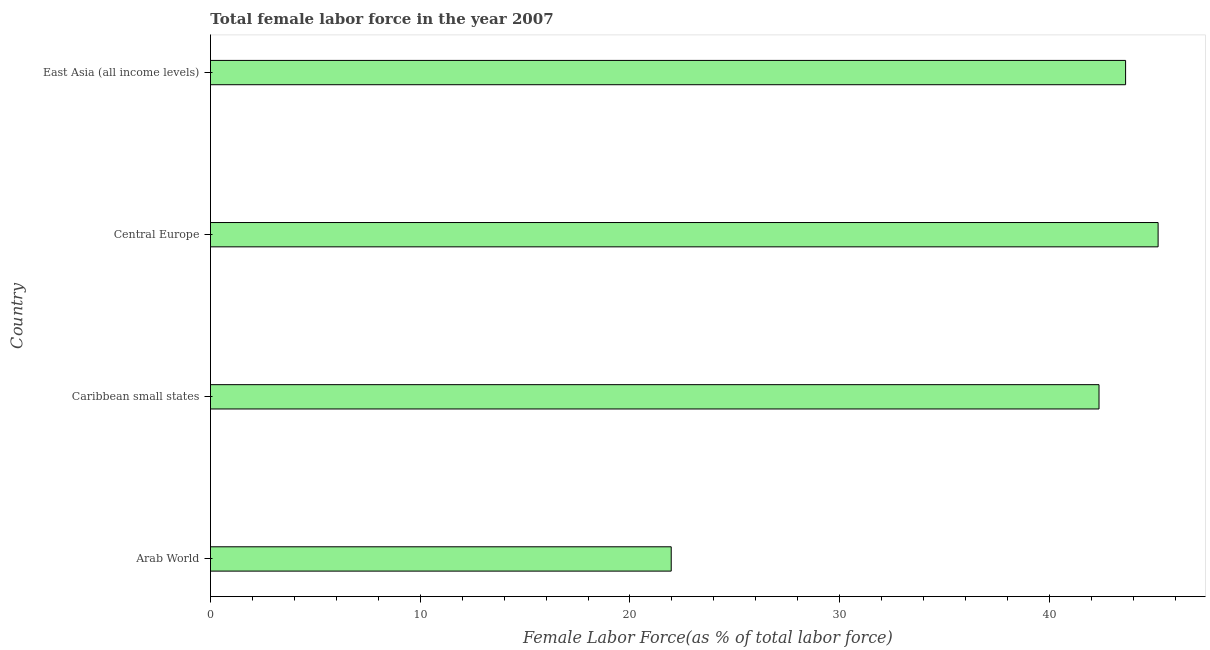Does the graph contain any zero values?
Ensure brevity in your answer.  No. What is the title of the graph?
Provide a succinct answer. Total female labor force in the year 2007. What is the label or title of the X-axis?
Offer a terse response. Female Labor Force(as % of total labor force). What is the total female labor force in Arab World?
Your response must be concise. 21.97. Across all countries, what is the maximum total female labor force?
Ensure brevity in your answer.  45.18. Across all countries, what is the minimum total female labor force?
Your answer should be compact. 21.97. In which country was the total female labor force maximum?
Your answer should be compact. Central Europe. In which country was the total female labor force minimum?
Provide a short and direct response. Arab World. What is the sum of the total female labor force?
Your response must be concise. 153.15. What is the difference between the total female labor force in Central Europe and East Asia (all income levels)?
Your answer should be very brief. 1.55. What is the average total female labor force per country?
Provide a succinct answer. 38.29. What is the median total female labor force?
Your response must be concise. 43. What is the ratio of the total female labor force in Arab World to that in Caribbean small states?
Offer a very short reply. 0.52. Is the total female labor force in Caribbean small states less than that in Central Europe?
Ensure brevity in your answer.  Yes. What is the difference between the highest and the second highest total female labor force?
Provide a short and direct response. 1.55. Is the sum of the total female labor force in Arab World and East Asia (all income levels) greater than the maximum total female labor force across all countries?
Ensure brevity in your answer.  Yes. What is the difference between the highest and the lowest total female labor force?
Your response must be concise. 23.21. In how many countries, is the total female labor force greater than the average total female labor force taken over all countries?
Give a very brief answer. 3. Are all the bars in the graph horizontal?
Your answer should be compact. Yes. How many countries are there in the graph?
Your response must be concise. 4. Are the values on the major ticks of X-axis written in scientific E-notation?
Provide a short and direct response. No. What is the Female Labor Force(as % of total labor force) of Arab World?
Ensure brevity in your answer.  21.97. What is the Female Labor Force(as % of total labor force) in Caribbean small states?
Ensure brevity in your answer.  42.36. What is the Female Labor Force(as % of total labor force) of Central Europe?
Your answer should be compact. 45.18. What is the Female Labor Force(as % of total labor force) in East Asia (all income levels)?
Make the answer very short. 43.63. What is the difference between the Female Labor Force(as % of total labor force) in Arab World and Caribbean small states?
Your response must be concise. -20.4. What is the difference between the Female Labor Force(as % of total labor force) in Arab World and Central Europe?
Your answer should be compact. -23.21. What is the difference between the Female Labor Force(as % of total labor force) in Arab World and East Asia (all income levels)?
Provide a succinct answer. -21.66. What is the difference between the Female Labor Force(as % of total labor force) in Caribbean small states and Central Europe?
Your answer should be very brief. -2.82. What is the difference between the Female Labor Force(as % of total labor force) in Caribbean small states and East Asia (all income levels)?
Offer a very short reply. -1.27. What is the difference between the Female Labor Force(as % of total labor force) in Central Europe and East Asia (all income levels)?
Offer a terse response. 1.55. What is the ratio of the Female Labor Force(as % of total labor force) in Arab World to that in Caribbean small states?
Ensure brevity in your answer.  0.52. What is the ratio of the Female Labor Force(as % of total labor force) in Arab World to that in Central Europe?
Make the answer very short. 0.49. What is the ratio of the Female Labor Force(as % of total labor force) in Arab World to that in East Asia (all income levels)?
Keep it short and to the point. 0.5. What is the ratio of the Female Labor Force(as % of total labor force) in Caribbean small states to that in Central Europe?
Offer a terse response. 0.94. What is the ratio of the Female Labor Force(as % of total labor force) in Caribbean small states to that in East Asia (all income levels)?
Give a very brief answer. 0.97. What is the ratio of the Female Labor Force(as % of total labor force) in Central Europe to that in East Asia (all income levels)?
Your answer should be compact. 1.04. 